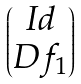<formula> <loc_0><loc_0><loc_500><loc_500>\begin{pmatrix} I d \\ D f _ { 1 } \end{pmatrix}</formula> 